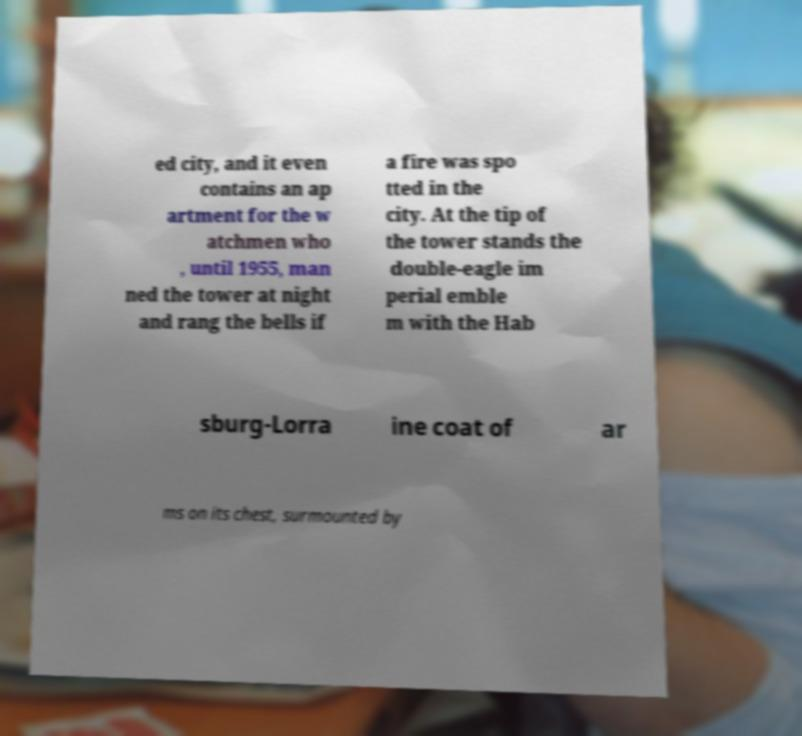For documentation purposes, I need the text within this image transcribed. Could you provide that? ed city, and it even contains an ap artment for the w atchmen who , until 1955, man ned the tower at night and rang the bells if a fire was spo tted in the city. At the tip of the tower stands the double-eagle im perial emble m with the Hab sburg-Lorra ine coat of ar ms on its chest, surmounted by 